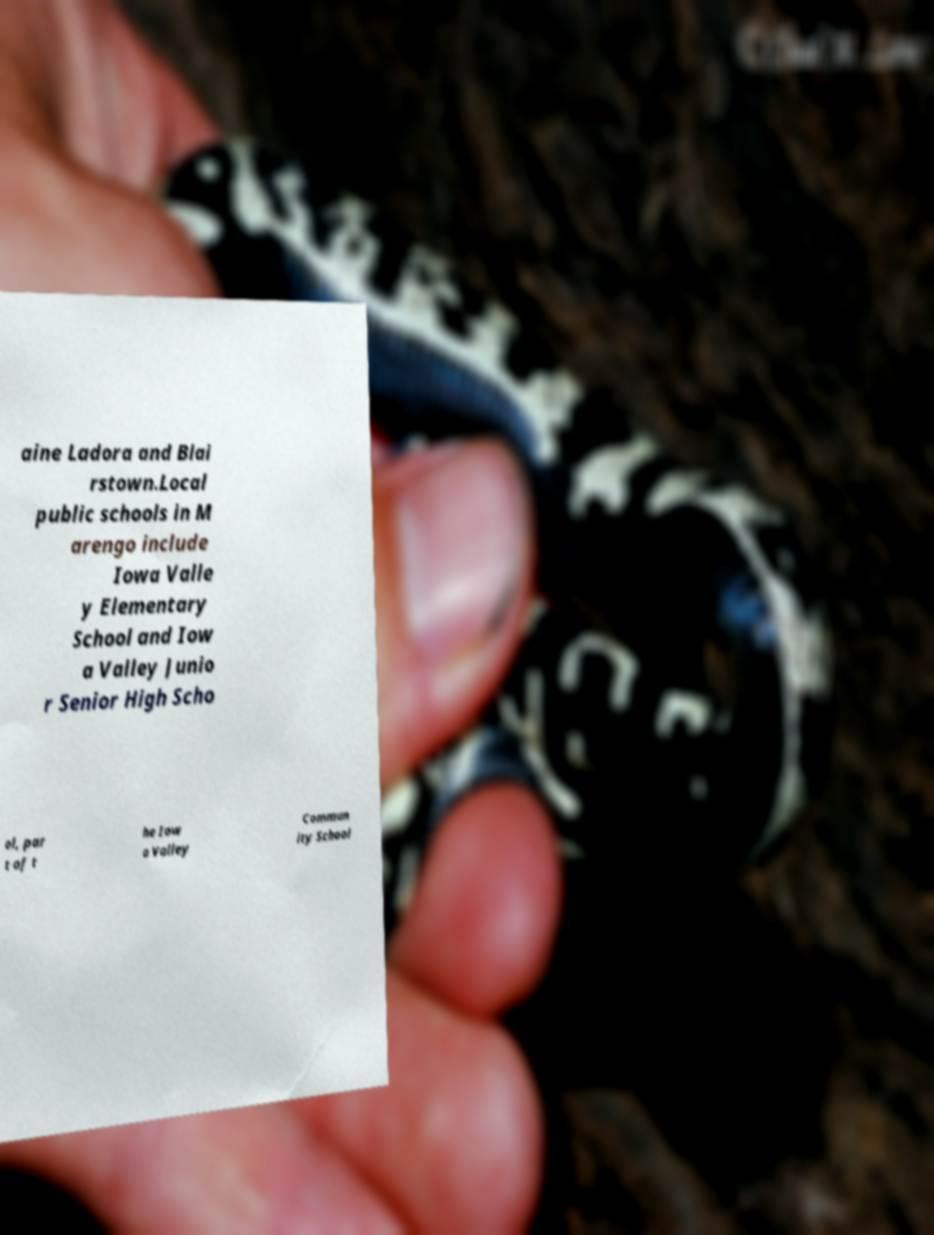Please read and relay the text visible in this image. What does it say? aine Ladora and Blai rstown.Local public schools in M arengo include Iowa Valle y Elementary School and Iow a Valley Junio r Senior High Scho ol, par t of t he Iow a Valley Commun ity School 